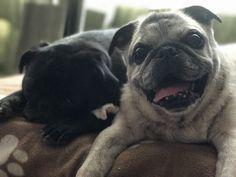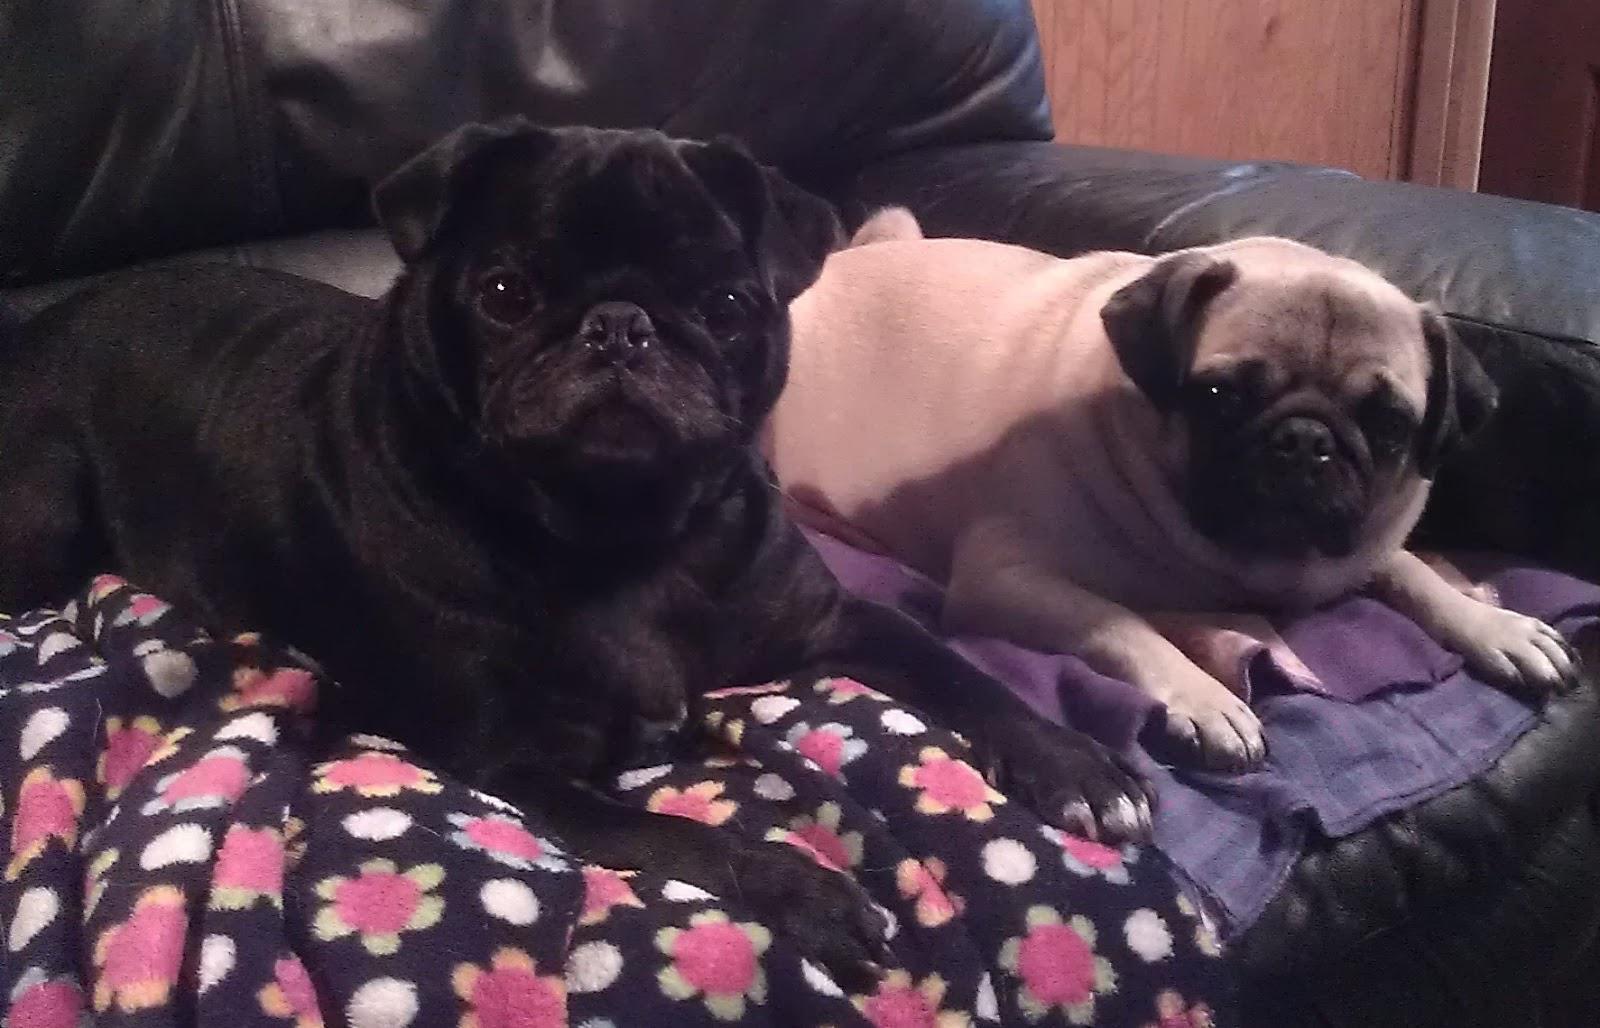The first image is the image on the left, the second image is the image on the right. For the images displayed, is the sentence "The majority of dogs pictured are black, and one image contains only black-colored pugs." factually correct? Answer yes or no. No. The first image is the image on the left, the second image is the image on the right. Analyze the images presented: Is the assertion "At least one of the dogs is wearing something around its neck." valid? Answer yes or no. No. 